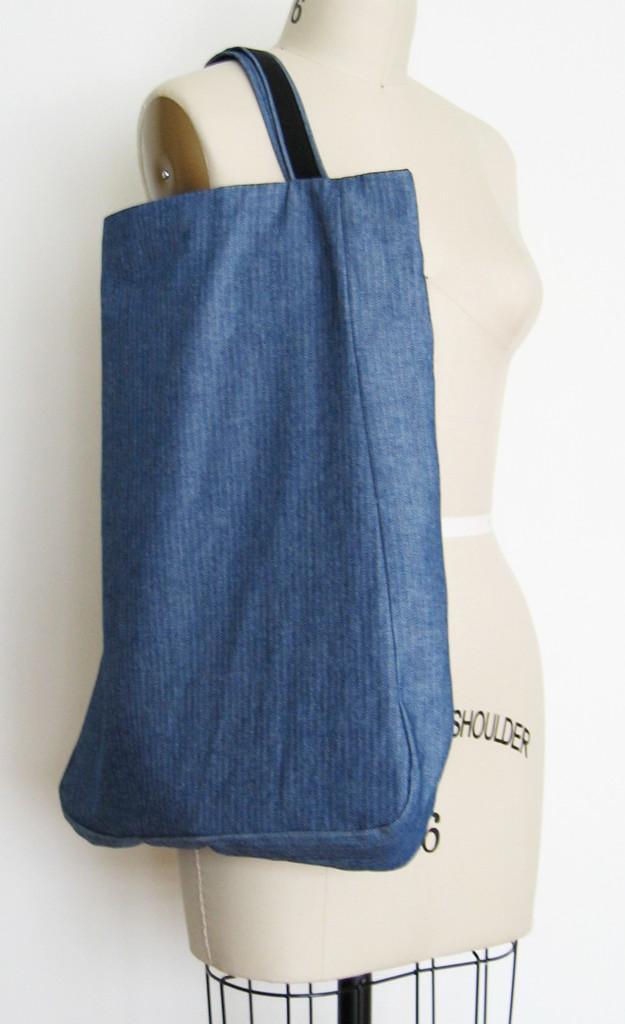Can you describe this image briefly? This picture is mainly highlighted with a mannequin and a blue colour bag on it. 